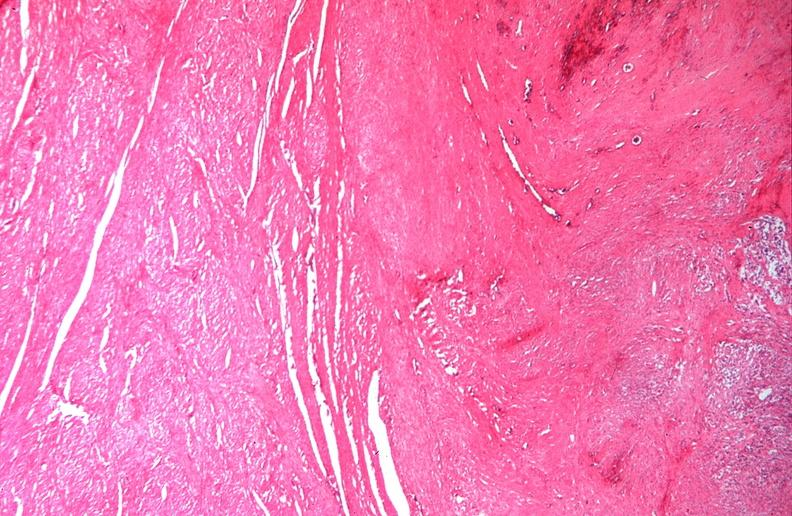what is present?
Answer the question using a single word or phrase. Female reproductive 